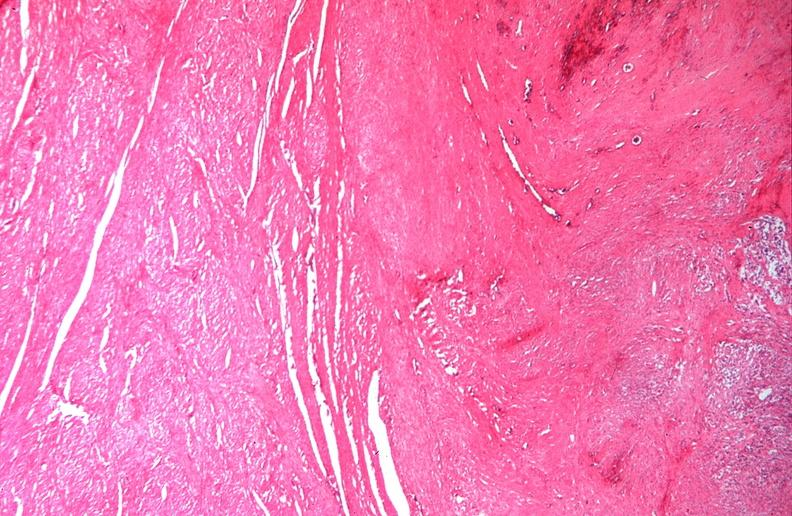what is present?
Answer the question using a single word or phrase. Female reproductive 